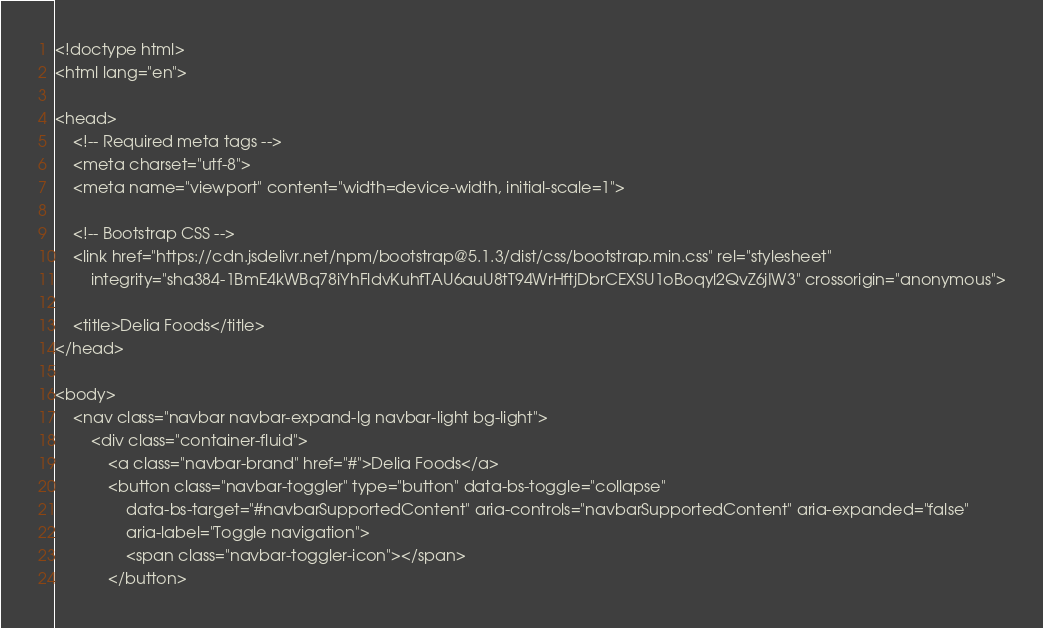<code> <loc_0><loc_0><loc_500><loc_500><_PHP_><!doctype html>
<html lang="en">

<head>
    <!-- Required meta tags -->
    <meta charset="utf-8">
    <meta name="viewport" content="width=device-width, initial-scale=1">

    <!-- Bootstrap CSS -->
    <link href="https://cdn.jsdelivr.net/npm/bootstrap@5.1.3/dist/css/bootstrap.min.css" rel="stylesheet"
        integrity="sha384-1BmE4kWBq78iYhFldvKuhfTAU6auU8tT94WrHftjDbrCEXSU1oBoqyl2QvZ6jIW3" crossorigin="anonymous">

    <title>Delia Foods</title>
</head>

<body>
    <nav class="navbar navbar-expand-lg navbar-light bg-light">
        <div class="container-fluid">
            <a class="navbar-brand" href="#">Delia Foods</a>
            <button class="navbar-toggler" type="button" data-bs-toggle="collapse"
                data-bs-target="#navbarSupportedContent" aria-controls="navbarSupportedContent" aria-expanded="false"
                aria-label="Toggle navigation">
                <span class="navbar-toggler-icon"></span>
            </button></code> 